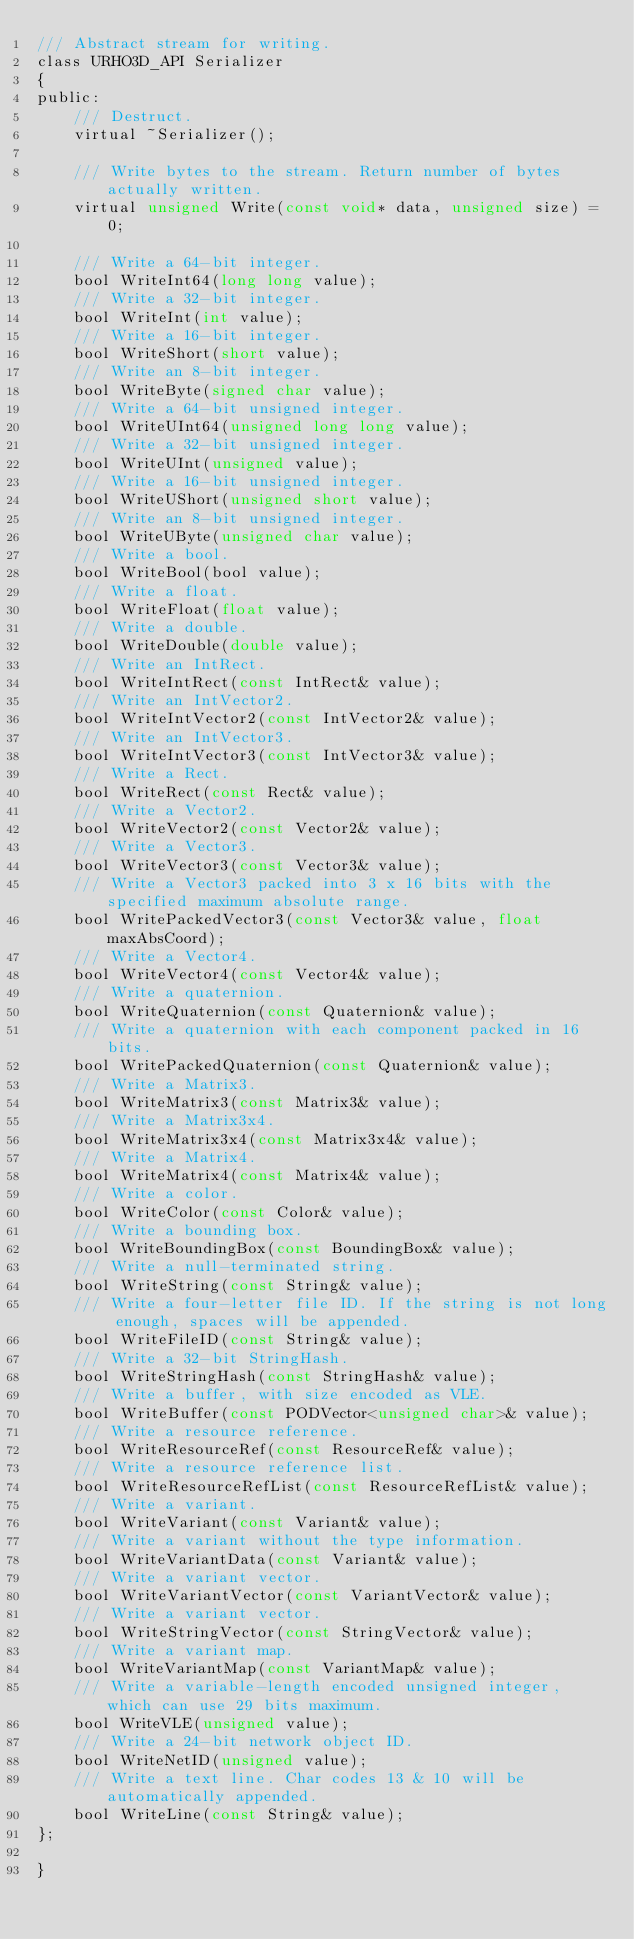<code> <loc_0><loc_0><loc_500><loc_500><_C_>/// Abstract stream for writing.
class URHO3D_API Serializer
{
public:
    /// Destruct.
    virtual ~Serializer();

    /// Write bytes to the stream. Return number of bytes actually written.
    virtual unsigned Write(const void* data, unsigned size) = 0;

    /// Write a 64-bit integer.
    bool WriteInt64(long long value);
    /// Write a 32-bit integer.
    bool WriteInt(int value);
    /// Write a 16-bit integer.
    bool WriteShort(short value);
    /// Write an 8-bit integer.
    bool WriteByte(signed char value);
    /// Write a 64-bit unsigned integer.
    bool WriteUInt64(unsigned long long value);
    /// Write a 32-bit unsigned integer.
    bool WriteUInt(unsigned value);
    /// Write a 16-bit unsigned integer.
    bool WriteUShort(unsigned short value);
    /// Write an 8-bit unsigned integer.
    bool WriteUByte(unsigned char value);
    /// Write a bool.
    bool WriteBool(bool value);
    /// Write a float.
    bool WriteFloat(float value);
    /// Write a double.
    bool WriteDouble(double value);
    /// Write an IntRect.
    bool WriteIntRect(const IntRect& value);
    /// Write an IntVector2.
    bool WriteIntVector2(const IntVector2& value);
    /// Write an IntVector3.
    bool WriteIntVector3(const IntVector3& value);
    /// Write a Rect.
    bool WriteRect(const Rect& value);
    /// Write a Vector2.
    bool WriteVector2(const Vector2& value);
    /// Write a Vector3.
    bool WriteVector3(const Vector3& value);
    /// Write a Vector3 packed into 3 x 16 bits with the specified maximum absolute range.
    bool WritePackedVector3(const Vector3& value, float maxAbsCoord);
    /// Write a Vector4.
    bool WriteVector4(const Vector4& value);
    /// Write a quaternion.
    bool WriteQuaternion(const Quaternion& value);
    /// Write a quaternion with each component packed in 16 bits.
    bool WritePackedQuaternion(const Quaternion& value);
    /// Write a Matrix3.
    bool WriteMatrix3(const Matrix3& value);
    /// Write a Matrix3x4.
    bool WriteMatrix3x4(const Matrix3x4& value);
    /// Write a Matrix4.
    bool WriteMatrix4(const Matrix4& value);
    /// Write a color.
    bool WriteColor(const Color& value);
    /// Write a bounding box.
    bool WriteBoundingBox(const BoundingBox& value);
    /// Write a null-terminated string.
    bool WriteString(const String& value);
    /// Write a four-letter file ID. If the string is not long enough, spaces will be appended.
    bool WriteFileID(const String& value);
    /// Write a 32-bit StringHash.
    bool WriteStringHash(const StringHash& value);
    /// Write a buffer, with size encoded as VLE.
    bool WriteBuffer(const PODVector<unsigned char>& value);
    /// Write a resource reference.
    bool WriteResourceRef(const ResourceRef& value);
    /// Write a resource reference list.
    bool WriteResourceRefList(const ResourceRefList& value);
    /// Write a variant.
    bool WriteVariant(const Variant& value);
    /// Write a variant without the type information.
    bool WriteVariantData(const Variant& value);
    /// Write a variant vector.
    bool WriteVariantVector(const VariantVector& value);
    /// Write a variant vector.
    bool WriteStringVector(const StringVector& value);
    /// Write a variant map.
    bool WriteVariantMap(const VariantMap& value);
    /// Write a variable-length encoded unsigned integer, which can use 29 bits maximum.
    bool WriteVLE(unsigned value);
    /// Write a 24-bit network object ID.
    bool WriteNetID(unsigned value);
    /// Write a text line. Char codes 13 & 10 will be automatically appended.
    bool WriteLine(const String& value);
};

}
</code> 